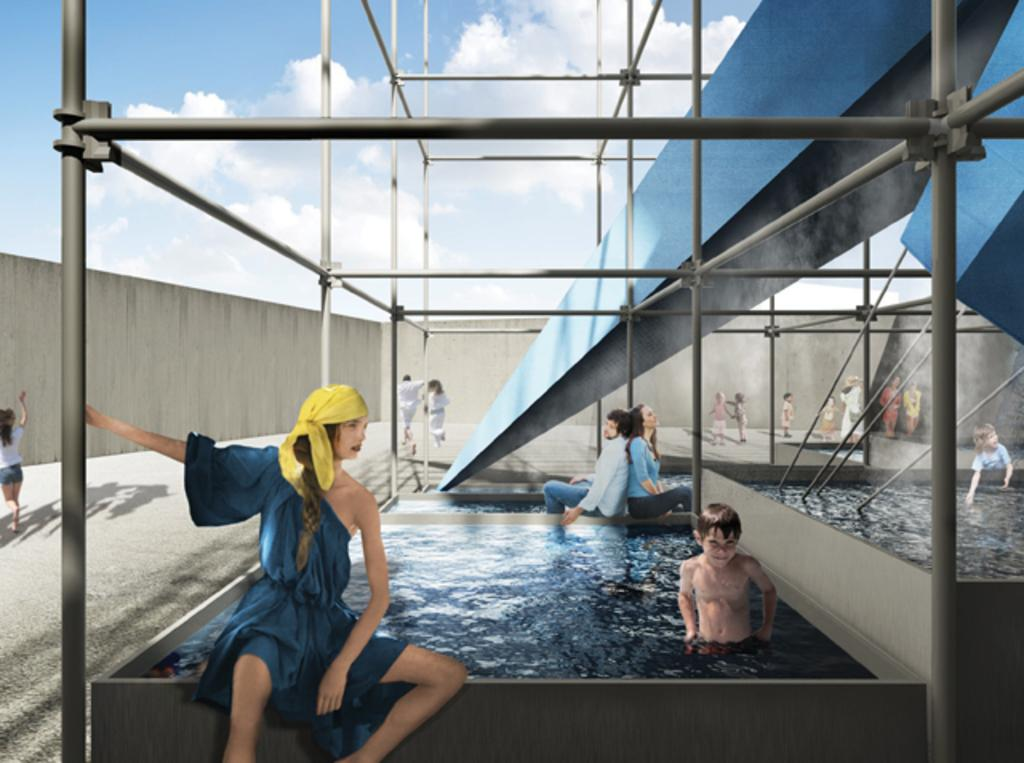What is the main subject in the middle of the image? There is a swimming pool in the middle of the image. Who or what is inside the swimming pool? There is a kid in the swimming pool. What can be seen at the top of the image? There are iron rods at the top of the image. What is located on the left side of the image? There is a wall on the left side of the image. How would you describe the style of the image? The image appears to be a digital art. What type of plantation can be seen near the swimming pool in the image? There is no plantation present in the image; it features a swimming pool, a kid, iron rods, and a wall. 